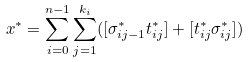<formula> <loc_0><loc_0><loc_500><loc_500>x ^ { * } = \sum _ { i = 0 } ^ { n - 1 } \sum _ { j = 1 } ^ { k _ { i } } ( [ \sigma _ { i j - 1 } ^ { * } t _ { i j } ^ { * } ] + [ t _ { i j } ^ { * } \sigma _ { i j } ^ { * } ] )</formula> 